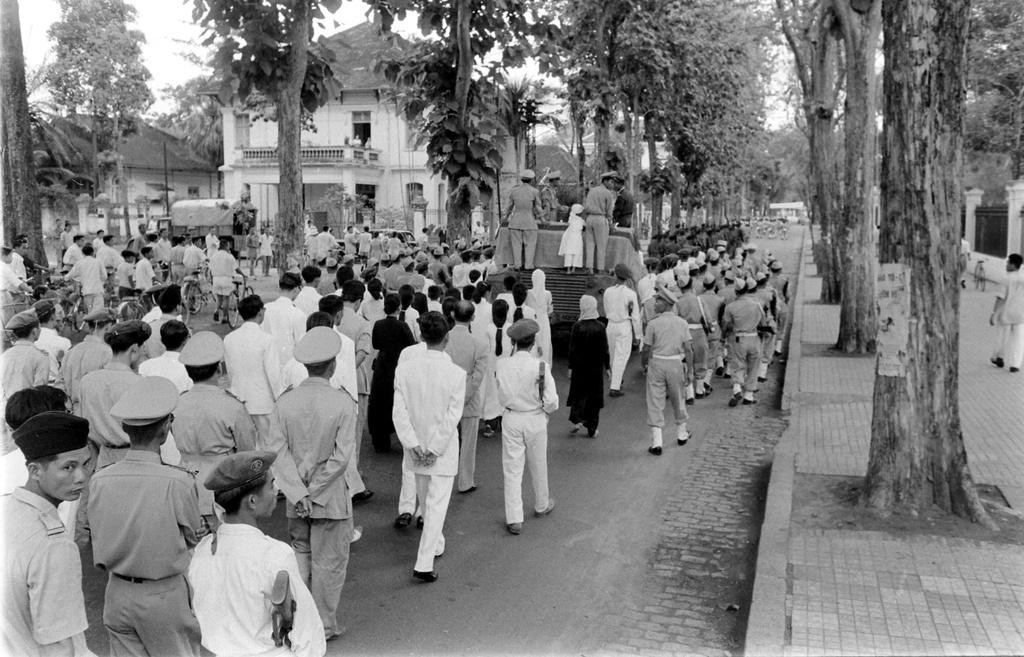How many people are in the image? There is a group of people in the image. What are some of the people doing in the image? Some people are standing, and some people are walking. What else can be seen in the image besides people? There are vehicles, trees, houses, and walls in the image. What type of pencil can be seen in the hands of the mom in the image? There is no mom present in the image, and therefore no pencil can be seen in her hands. 